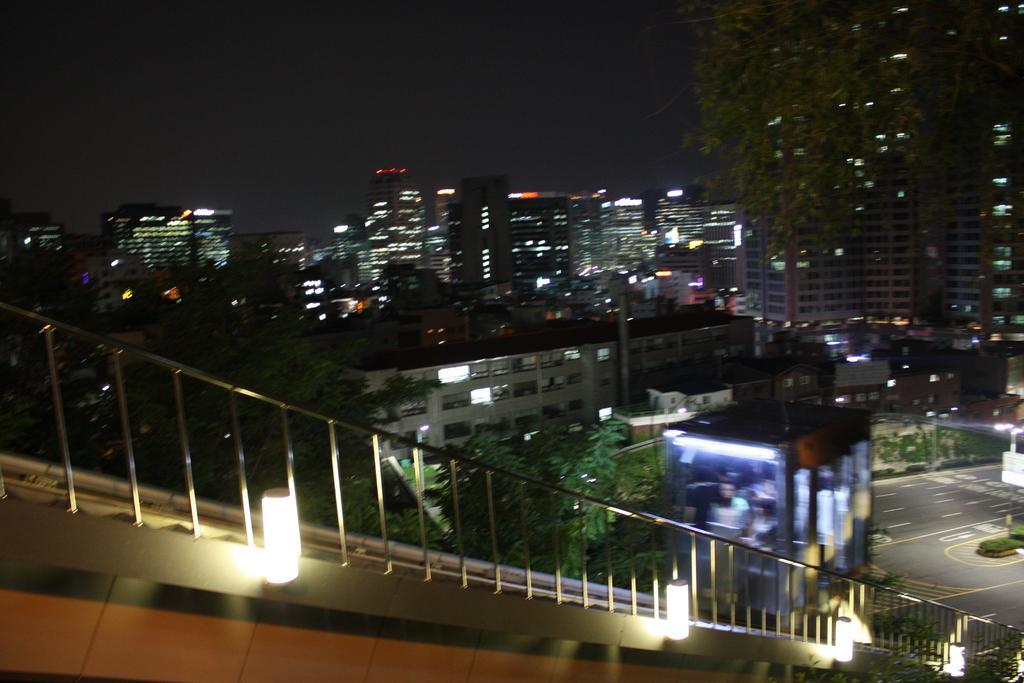Please provide a concise description of this image. In this image I can see few lights, railing. In the background I can see few trees in green color, few buildings and the sky is in black color. 